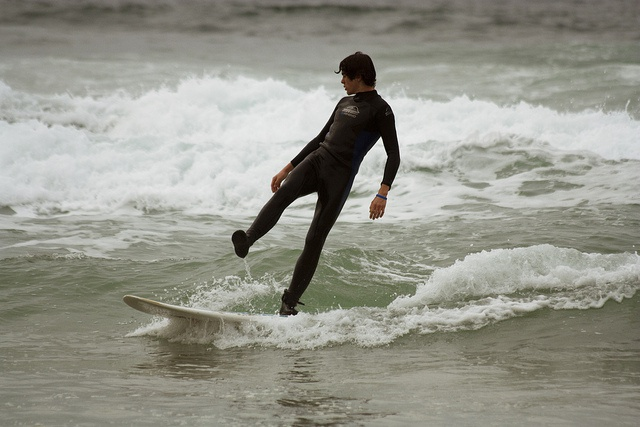Describe the objects in this image and their specific colors. I can see people in gray, black, lightgray, maroon, and darkgray tones and surfboard in gray and darkgray tones in this image. 